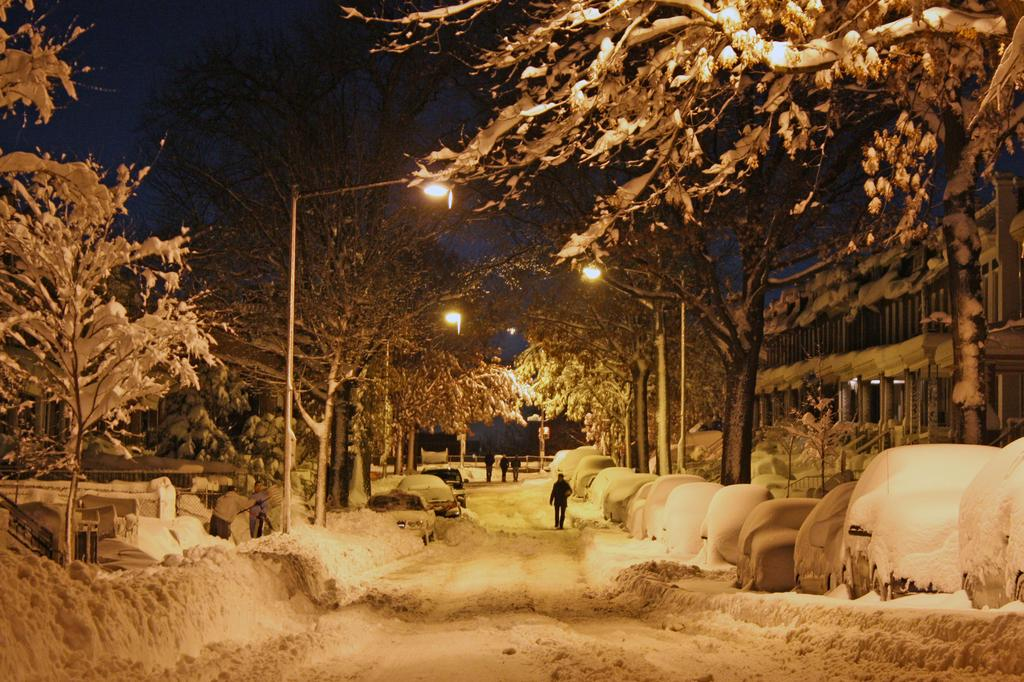What type of vegetation is present in the image? There are trees in the image. What can be seen illuminating the scene in the image? There are street lights in the image. What weather condition is depicted in the image? It is snowing in the image. Are there any people visible in the image? Yes, there are people standing in the image. How are the cars affected by the snow in the image? The cars are covered with snow in the image. What type of structure is present in the background of the image? There is a building in the image. What type of shop can be seen in the image? There is no shop present in the image. 